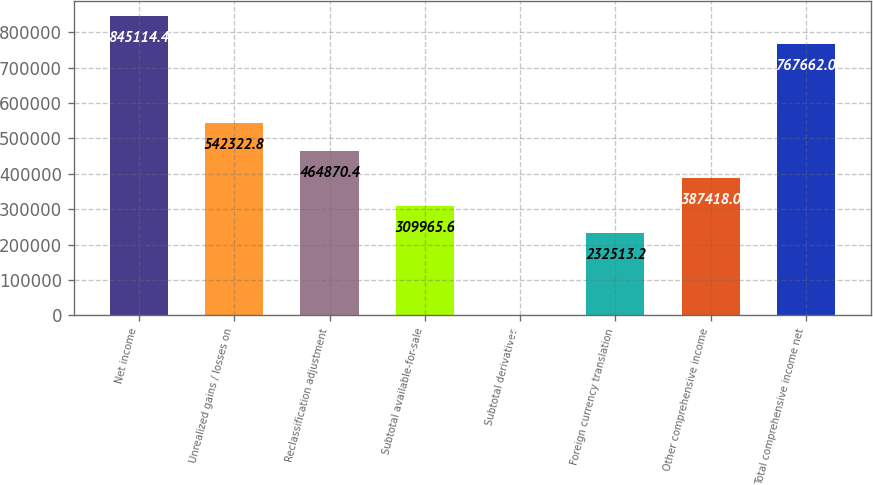Convert chart to OTSL. <chart><loc_0><loc_0><loc_500><loc_500><bar_chart><fcel>Net income<fcel>Unrealized gains / losses on<fcel>Reclassification adjustment<fcel>Subtotal available-for-sale<fcel>Subtotal derivatives<fcel>Foreign currency translation<fcel>Other comprehensive income<fcel>Total comprehensive income net<nl><fcel>845114<fcel>542323<fcel>464870<fcel>309966<fcel>156<fcel>232513<fcel>387418<fcel>767662<nl></chart> 